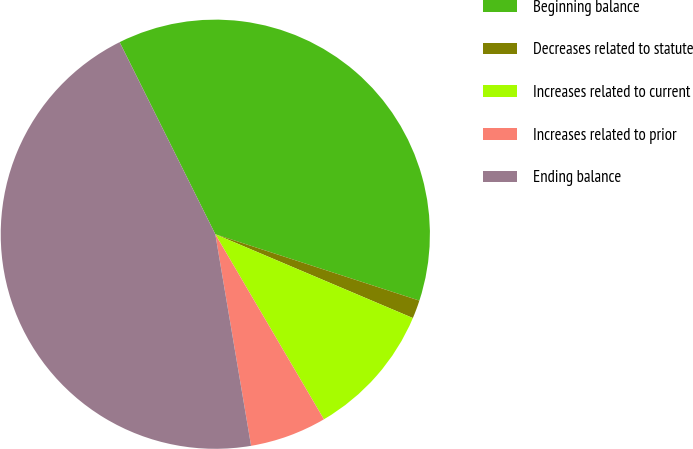Convert chart. <chart><loc_0><loc_0><loc_500><loc_500><pie_chart><fcel>Beginning balance<fcel>Decreases related to statute<fcel>Increases related to current<fcel>Increases related to prior<fcel>Ending balance<nl><fcel>37.36%<fcel>1.38%<fcel>10.17%<fcel>5.78%<fcel>45.31%<nl></chart> 